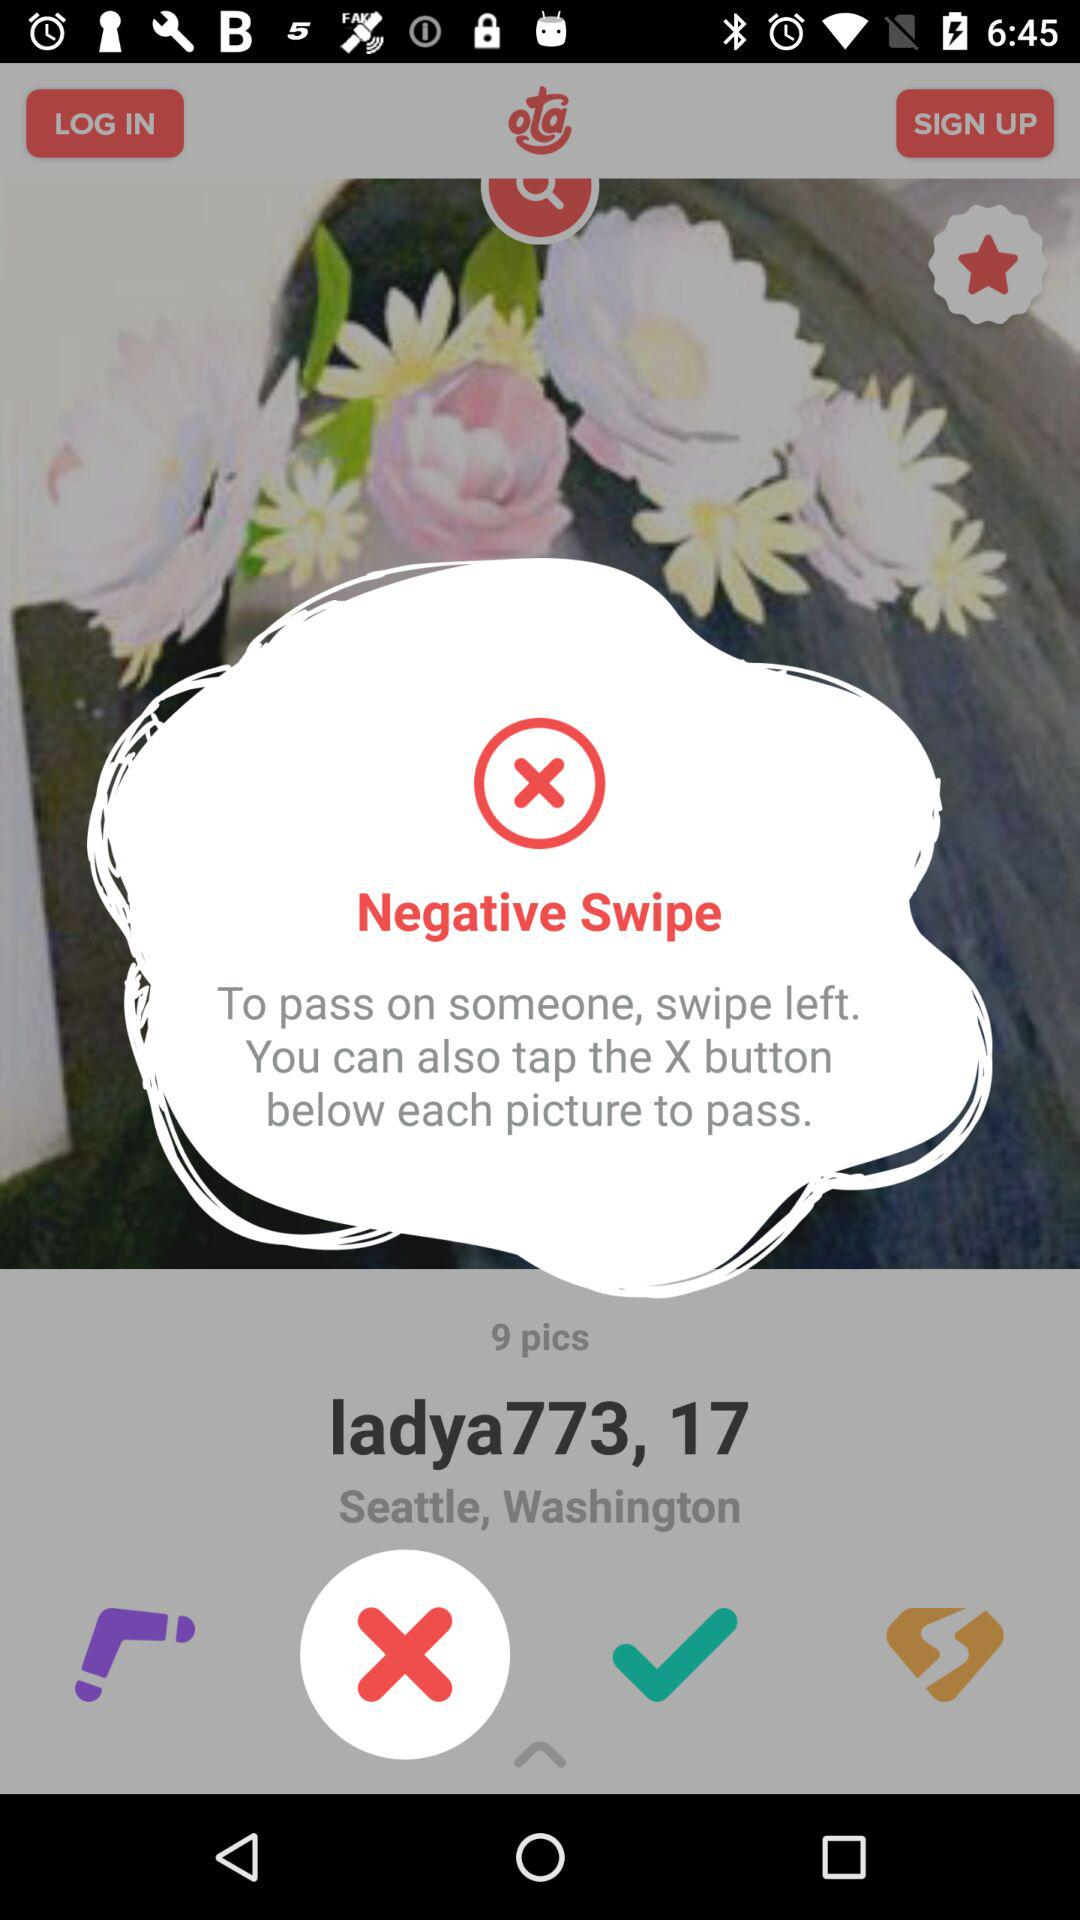What is the location? The location is Seattle, Washington. 